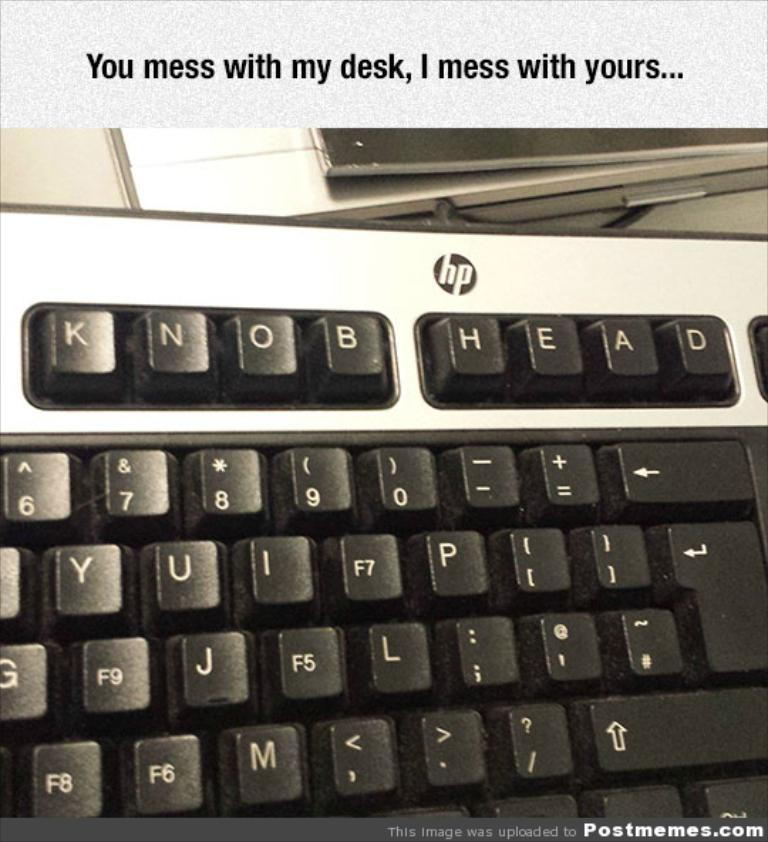Provide a one-sentence caption for the provided image. As payback, his coworker changed the keys on his hp keyboard to read knob head!. 